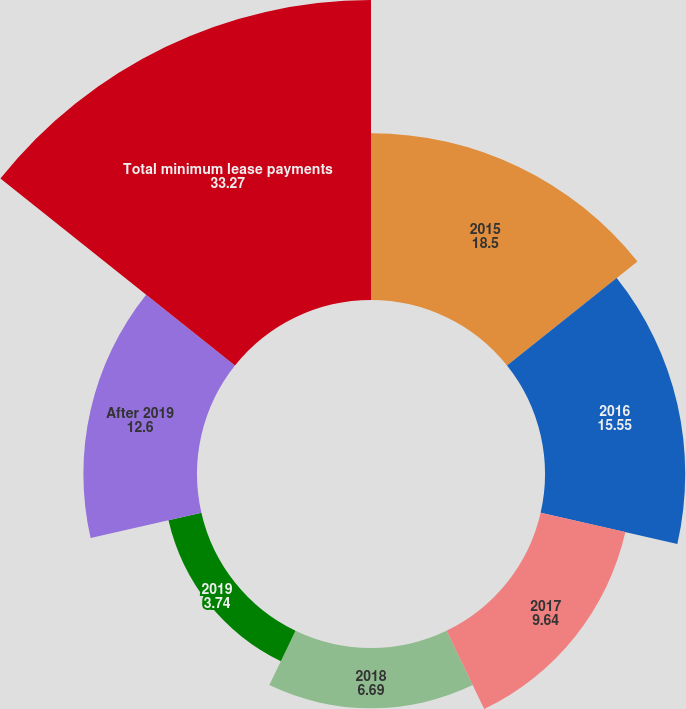Convert chart to OTSL. <chart><loc_0><loc_0><loc_500><loc_500><pie_chart><fcel>2015<fcel>2016<fcel>2017<fcel>2018<fcel>2019<fcel>After 2019<fcel>Total minimum lease payments<nl><fcel>18.5%<fcel>15.55%<fcel>9.64%<fcel>6.69%<fcel>3.74%<fcel>12.6%<fcel>33.27%<nl></chart> 